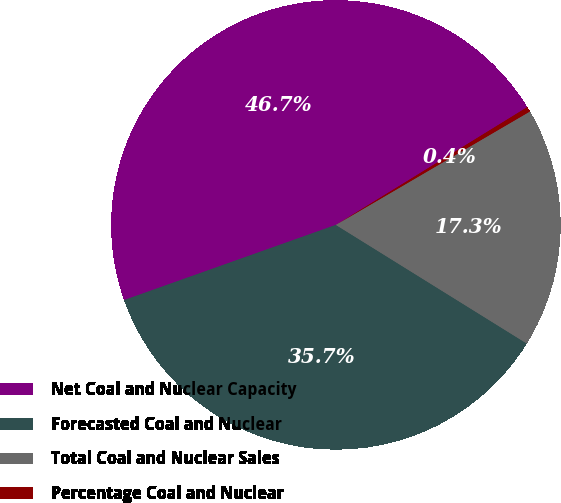<chart> <loc_0><loc_0><loc_500><loc_500><pie_chart><fcel>Net Coal and Nuclear Capacity<fcel>Forecasted Coal and Nuclear<fcel>Total Coal and Nuclear Sales<fcel>Percentage Coal and Nuclear<nl><fcel>46.65%<fcel>35.72%<fcel>17.27%<fcel>0.36%<nl></chart> 